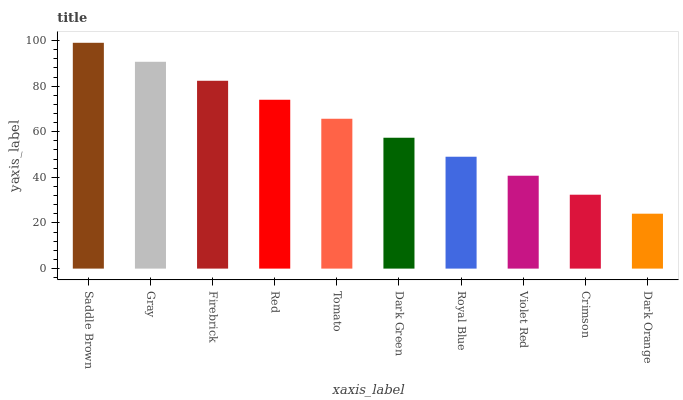Is Gray the minimum?
Answer yes or no. No. Is Gray the maximum?
Answer yes or no. No. Is Saddle Brown greater than Gray?
Answer yes or no. Yes. Is Gray less than Saddle Brown?
Answer yes or no. Yes. Is Gray greater than Saddle Brown?
Answer yes or no. No. Is Saddle Brown less than Gray?
Answer yes or no. No. Is Tomato the high median?
Answer yes or no. Yes. Is Dark Green the low median?
Answer yes or no. Yes. Is Dark Green the high median?
Answer yes or no. No. Is Dark Orange the low median?
Answer yes or no. No. 